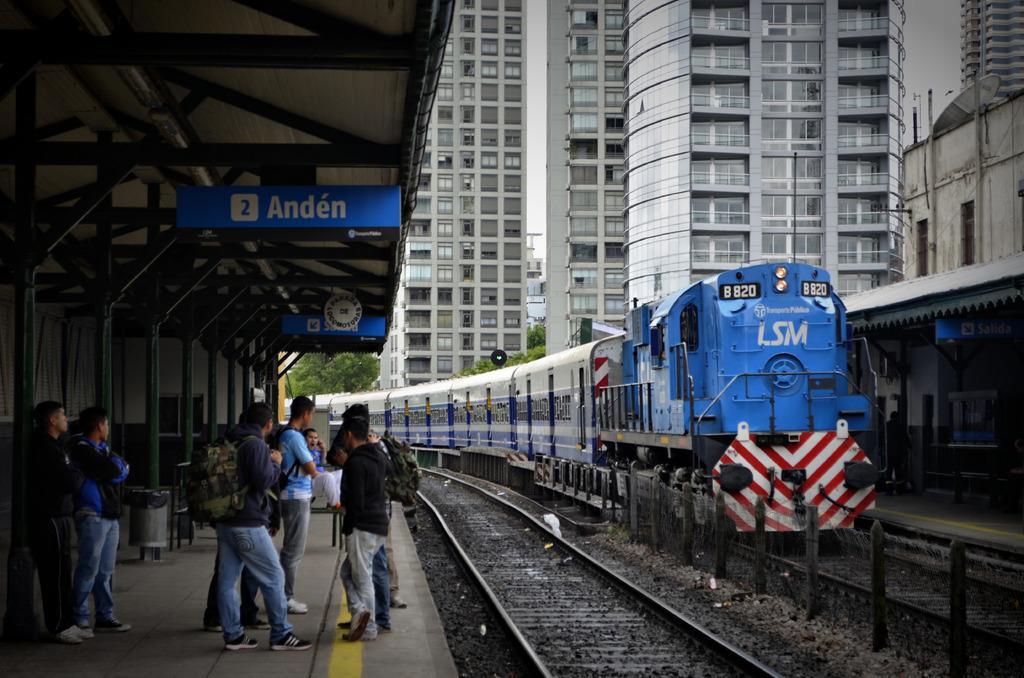Describe this image in one or two sentences. On the left side, there are persons standing on a platform. Above them, there are hoardings attached to the roof. On the right side, there is a train on the railway track. Beside this railway track, there is another railway track and a platform which is having roof. In the background, there are buildings which are having glass windows and there are trees. 